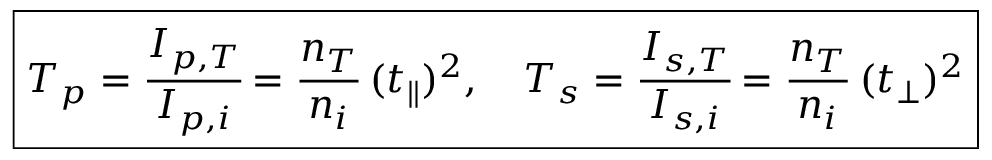<formula> <loc_0><loc_0><loc_500><loc_500>\boxed { T _ { p } = \cfrac { I _ { p , T } } { I _ { p , i } } = \cfrac { n _ { T } } { n _ { i } } \, ( t _ { \| } ) ^ { 2 } , \quad T _ { s } = \cfrac { I _ { s , T } } { I _ { s , i } } = \cfrac { n _ { T } } { n _ { i } } \, ( t _ { \perp } ) ^ { 2 } }</formula> 